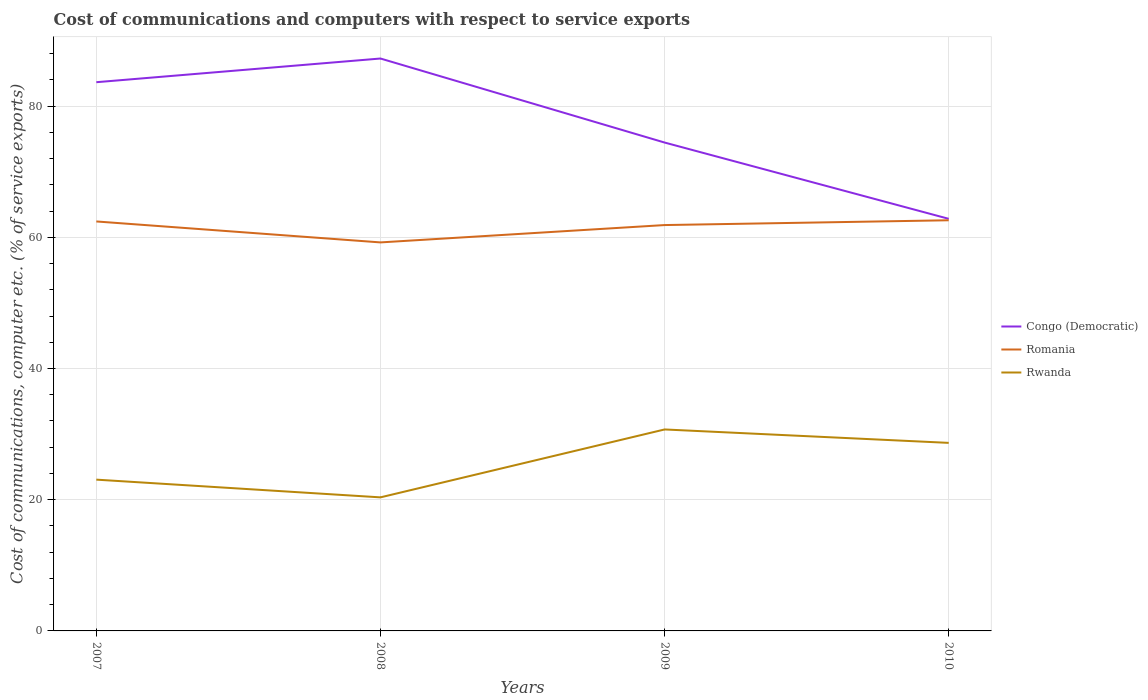Does the line corresponding to Romania intersect with the line corresponding to Congo (Democratic)?
Your answer should be very brief. No. Across all years, what is the maximum cost of communications and computers in Congo (Democratic)?
Ensure brevity in your answer.  62.82. What is the total cost of communications and computers in Congo (Democratic) in the graph?
Your response must be concise. 12.81. What is the difference between the highest and the second highest cost of communications and computers in Congo (Democratic)?
Your answer should be compact. 24.43. What is the difference between two consecutive major ticks on the Y-axis?
Provide a succinct answer. 20. Where does the legend appear in the graph?
Provide a succinct answer. Center right. How are the legend labels stacked?
Make the answer very short. Vertical. What is the title of the graph?
Make the answer very short. Cost of communications and computers with respect to service exports. Does "Morocco" appear as one of the legend labels in the graph?
Offer a very short reply. No. What is the label or title of the Y-axis?
Keep it short and to the point. Cost of communications, computer etc. (% of service exports). What is the Cost of communications, computer etc. (% of service exports) of Congo (Democratic) in 2007?
Provide a succinct answer. 83.64. What is the Cost of communications, computer etc. (% of service exports) of Romania in 2007?
Give a very brief answer. 62.41. What is the Cost of communications, computer etc. (% of service exports) in Rwanda in 2007?
Keep it short and to the point. 23.06. What is the Cost of communications, computer etc. (% of service exports) in Congo (Democratic) in 2008?
Your answer should be compact. 87.25. What is the Cost of communications, computer etc. (% of service exports) in Romania in 2008?
Keep it short and to the point. 59.22. What is the Cost of communications, computer etc. (% of service exports) in Rwanda in 2008?
Make the answer very short. 20.36. What is the Cost of communications, computer etc. (% of service exports) of Congo (Democratic) in 2009?
Your response must be concise. 74.44. What is the Cost of communications, computer etc. (% of service exports) of Romania in 2009?
Your response must be concise. 61.86. What is the Cost of communications, computer etc. (% of service exports) in Rwanda in 2009?
Give a very brief answer. 30.71. What is the Cost of communications, computer etc. (% of service exports) of Congo (Democratic) in 2010?
Keep it short and to the point. 62.82. What is the Cost of communications, computer etc. (% of service exports) in Romania in 2010?
Your answer should be compact. 62.59. What is the Cost of communications, computer etc. (% of service exports) of Rwanda in 2010?
Provide a short and direct response. 28.66. Across all years, what is the maximum Cost of communications, computer etc. (% of service exports) of Congo (Democratic)?
Keep it short and to the point. 87.25. Across all years, what is the maximum Cost of communications, computer etc. (% of service exports) in Romania?
Provide a succinct answer. 62.59. Across all years, what is the maximum Cost of communications, computer etc. (% of service exports) of Rwanda?
Your response must be concise. 30.71. Across all years, what is the minimum Cost of communications, computer etc. (% of service exports) in Congo (Democratic)?
Offer a very short reply. 62.82. Across all years, what is the minimum Cost of communications, computer etc. (% of service exports) in Romania?
Your answer should be very brief. 59.22. Across all years, what is the minimum Cost of communications, computer etc. (% of service exports) of Rwanda?
Ensure brevity in your answer.  20.36. What is the total Cost of communications, computer etc. (% of service exports) of Congo (Democratic) in the graph?
Make the answer very short. 308.15. What is the total Cost of communications, computer etc. (% of service exports) in Romania in the graph?
Give a very brief answer. 246.09. What is the total Cost of communications, computer etc. (% of service exports) in Rwanda in the graph?
Offer a terse response. 102.79. What is the difference between the Cost of communications, computer etc. (% of service exports) in Congo (Democratic) in 2007 and that in 2008?
Keep it short and to the point. -3.61. What is the difference between the Cost of communications, computer etc. (% of service exports) of Romania in 2007 and that in 2008?
Offer a terse response. 3.19. What is the difference between the Cost of communications, computer etc. (% of service exports) in Rwanda in 2007 and that in 2008?
Offer a terse response. 2.7. What is the difference between the Cost of communications, computer etc. (% of service exports) in Congo (Democratic) in 2007 and that in 2009?
Your answer should be compact. 9.2. What is the difference between the Cost of communications, computer etc. (% of service exports) of Romania in 2007 and that in 2009?
Offer a very short reply. 0.55. What is the difference between the Cost of communications, computer etc. (% of service exports) in Rwanda in 2007 and that in 2009?
Offer a very short reply. -7.65. What is the difference between the Cost of communications, computer etc. (% of service exports) in Congo (Democratic) in 2007 and that in 2010?
Provide a succinct answer. 20.82. What is the difference between the Cost of communications, computer etc. (% of service exports) in Romania in 2007 and that in 2010?
Your answer should be compact. -0.18. What is the difference between the Cost of communications, computer etc. (% of service exports) of Rwanda in 2007 and that in 2010?
Provide a short and direct response. -5.61. What is the difference between the Cost of communications, computer etc. (% of service exports) in Congo (Democratic) in 2008 and that in 2009?
Your answer should be compact. 12.81. What is the difference between the Cost of communications, computer etc. (% of service exports) of Romania in 2008 and that in 2009?
Make the answer very short. -2.64. What is the difference between the Cost of communications, computer etc. (% of service exports) in Rwanda in 2008 and that in 2009?
Your answer should be very brief. -10.35. What is the difference between the Cost of communications, computer etc. (% of service exports) of Congo (Democratic) in 2008 and that in 2010?
Keep it short and to the point. 24.43. What is the difference between the Cost of communications, computer etc. (% of service exports) of Romania in 2008 and that in 2010?
Provide a succinct answer. -3.37. What is the difference between the Cost of communications, computer etc. (% of service exports) in Rwanda in 2008 and that in 2010?
Provide a succinct answer. -8.3. What is the difference between the Cost of communications, computer etc. (% of service exports) of Congo (Democratic) in 2009 and that in 2010?
Provide a short and direct response. 11.63. What is the difference between the Cost of communications, computer etc. (% of service exports) in Romania in 2009 and that in 2010?
Ensure brevity in your answer.  -0.73. What is the difference between the Cost of communications, computer etc. (% of service exports) of Rwanda in 2009 and that in 2010?
Provide a short and direct response. 2.04. What is the difference between the Cost of communications, computer etc. (% of service exports) in Congo (Democratic) in 2007 and the Cost of communications, computer etc. (% of service exports) in Romania in 2008?
Your answer should be very brief. 24.42. What is the difference between the Cost of communications, computer etc. (% of service exports) in Congo (Democratic) in 2007 and the Cost of communications, computer etc. (% of service exports) in Rwanda in 2008?
Give a very brief answer. 63.28. What is the difference between the Cost of communications, computer etc. (% of service exports) of Romania in 2007 and the Cost of communications, computer etc. (% of service exports) of Rwanda in 2008?
Your response must be concise. 42.05. What is the difference between the Cost of communications, computer etc. (% of service exports) of Congo (Democratic) in 2007 and the Cost of communications, computer etc. (% of service exports) of Romania in 2009?
Provide a short and direct response. 21.78. What is the difference between the Cost of communications, computer etc. (% of service exports) in Congo (Democratic) in 2007 and the Cost of communications, computer etc. (% of service exports) in Rwanda in 2009?
Your response must be concise. 52.93. What is the difference between the Cost of communications, computer etc. (% of service exports) of Romania in 2007 and the Cost of communications, computer etc. (% of service exports) of Rwanda in 2009?
Provide a short and direct response. 31.71. What is the difference between the Cost of communications, computer etc. (% of service exports) in Congo (Democratic) in 2007 and the Cost of communications, computer etc. (% of service exports) in Romania in 2010?
Your answer should be compact. 21.05. What is the difference between the Cost of communications, computer etc. (% of service exports) of Congo (Democratic) in 2007 and the Cost of communications, computer etc. (% of service exports) of Rwanda in 2010?
Give a very brief answer. 54.98. What is the difference between the Cost of communications, computer etc. (% of service exports) in Romania in 2007 and the Cost of communications, computer etc. (% of service exports) in Rwanda in 2010?
Your answer should be very brief. 33.75. What is the difference between the Cost of communications, computer etc. (% of service exports) in Congo (Democratic) in 2008 and the Cost of communications, computer etc. (% of service exports) in Romania in 2009?
Ensure brevity in your answer.  25.39. What is the difference between the Cost of communications, computer etc. (% of service exports) in Congo (Democratic) in 2008 and the Cost of communications, computer etc. (% of service exports) in Rwanda in 2009?
Offer a very short reply. 56.54. What is the difference between the Cost of communications, computer etc. (% of service exports) of Romania in 2008 and the Cost of communications, computer etc. (% of service exports) of Rwanda in 2009?
Your answer should be compact. 28.51. What is the difference between the Cost of communications, computer etc. (% of service exports) in Congo (Democratic) in 2008 and the Cost of communications, computer etc. (% of service exports) in Romania in 2010?
Give a very brief answer. 24.66. What is the difference between the Cost of communications, computer etc. (% of service exports) of Congo (Democratic) in 2008 and the Cost of communications, computer etc. (% of service exports) of Rwanda in 2010?
Offer a terse response. 58.59. What is the difference between the Cost of communications, computer etc. (% of service exports) in Romania in 2008 and the Cost of communications, computer etc. (% of service exports) in Rwanda in 2010?
Your response must be concise. 30.56. What is the difference between the Cost of communications, computer etc. (% of service exports) of Congo (Democratic) in 2009 and the Cost of communications, computer etc. (% of service exports) of Romania in 2010?
Make the answer very short. 11.85. What is the difference between the Cost of communications, computer etc. (% of service exports) of Congo (Democratic) in 2009 and the Cost of communications, computer etc. (% of service exports) of Rwanda in 2010?
Your response must be concise. 45.78. What is the difference between the Cost of communications, computer etc. (% of service exports) of Romania in 2009 and the Cost of communications, computer etc. (% of service exports) of Rwanda in 2010?
Offer a terse response. 33.2. What is the average Cost of communications, computer etc. (% of service exports) in Congo (Democratic) per year?
Your answer should be very brief. 77.04. What is the average Cost of communications, computer etc. (% of service exports) of Romania per year?
Give a very brief answer. 61.52. What is the average Cost of communications, computer etc. (% of service exports) in Rwanda per year?
Offer a very short reply. 25.7. In the year 2007, what is the difference between the Cost of communications, computer etc. (% of service exports) of Congo (Democratic) and Cost of communications, computer etc. (% of service exports) of Romania?
Your answer should be very brief. 21.23. In the year 2007, what is the difference between the Cost of communications, computer etc. (% of service exports) of Congo (Democratic) and Cost of communications, computer etc. (% of service exports) of Rwanda?
Make the answer very short. 60.58. In the year 2007, what is the difference between the Cost of communications, computer etc. (% of service exports) in Romania and Cost of communications, computer etc. (% of service exports) in Rwanda?
Ensure brevity in your answer.  39.36. In the year 2008, what is the difference between the Cost of communications, computer etc. (% of service exports) in Congo (Democratic) and Cost of communications, computer etc. (% of service exports) in Romania?
Keep it short and to the point. 28.03. In the year 2008, what is the difference between the Cost of communications, computer etc. (% of service exports) in Congo (Democratic) and Cost of communications, computer etc. (% of service exports) in Rwanda?
Offer a very short reply. 66.89. In the year 2008, what is the difference between the Cost of communications, computer etc. (% of service exports) of Romania and Cost of communications, computer etc. (% of service exports) of Rwanda?
Provide a short and direct response. 38.86. In the year 2009, what is the difference between the Cost of communications, computer etc. (% of service exports) in Congo (Democratic) and Cost of communications, computer etc. (% of service exports) in Romania?
Give a very brief answer. 12.58. In the year 2009, what is the difference between the Cost of communications, computer etc. (% of service exports) in Congo (Democratic) and Cost of communications, computer etc. (% of service exports) in Rwanda?
Provide a succinct answer. 43.73. In the year 2009, what is the difference between the Cost of communications, computer etc. (% of service exports) in Romania and Cost of communications, computer etc. (% of service exports) in Rwanda?
Provide a succinct answer. 31.15. In the year 2010, what is the difference between the Cost of communications, computer etc. (% of service exports) in Congo (Democratic) and Cost of communications, computer etc. (% of service exports) in Romania?
Your response must be concise. 0.22. In the year 2010, what is the difference between the Cost of communications, computer etc. (% of service exports) of Congo (Democratic) and Cost of communications, computer etc. (% of service exports) of Rwanda?
Provide a short and direct response. 34.15. In the year 2010, what is the difference between the Cost of communications, computer etc. (% of service exports) in Romania and Cost of communications, computer etc. (% of service exports) in Rwanda?
Offer a terse response. 33.93. What is the ratio of the Cost of communications, computer etc. (% of service exports) in Congo (Democratic) in 2007 to that in 2008?
Give a very brief answer. 0.96. What is the ratio of the Cost of communications, computer etc. (% of service exports) of Romania in 2007 to that in 2008?
Your answer should be very brief. 1.05. What is the ratio of the Cost of communications, computer etc. (% of service exports) in Rwanda in 2007 to that in 2008?
Provide a short and direct response. 1.13. What is the ratio of the Cost of communications, computer etc. (% of service exports) of Congo (Democratic) in 2007 to that in 2009?
Offer a very short reply. 1.12. What is the ratio of the Cost of communications, computer etc. (% of service exports) of Romania in 2007 to that in 2009?
Give a very brief answer. 1.01. What is the ratio of the Cost of communications, computer etc. (% of service exports) in Rwanda in 2007 to that in 2009?
Offer a very short reply. 0.75. What is the ratio of the Cost of communications, computer etc. (% of service exports) of Congo (Democratic) in 2007 to that in 2010?
Keep it short and to the point. 1.33. What is the ratio of the Cost of communications, computer etc. (% of service exports) in Romania in 2007 to that in 2010?
Provide a short and direct response. 1. What is the ratio of the Cost of communications, computer etc. (% of service exports) of Rwanda in 2007 to that in 2010?
Your response must be concise. 0.8. What is the ratio of the Cost of communications, computer etc. (% of service exports) in Congo (Democratic) in 2008 to that in 2009?
Your response must be concise. 1.17. What is the ratio of the Cost of communications, computer etc. (% of service exports) of Romania in 2008 to that in 2009?
Your answer should be compact. 0.96. What is the ratio of the Cost of communications, computer etc. (% of service exports) of Rwanda in 2008 to that in 2009?
Make the answer very short. 0.66. What is the ratio of the Cost of communications, computer etc. (% of service exports) of Congo (Democratic) in 2008 to that in 2010?
Provide a short and direct response. 1.39. What is the ratio of the Cost of communications, computer etc. (% of service exports) in Romania in 2008 to that in 2010?
Your answer should be very brief. 0.95. What is the ratio of the Cost of communications, computer etc. (% of service exports) of Rwanda in 2008 to that in 2010?
Keep it short and to the point. 0.71. What is the ratio of the Cost of communications, computer etc. (% of service exports) in Congo (Democratic) in 2009 to that in 2010?
Keep it short and to the point. 1.19. What is the ratio of the Cost of communications, computer etc. (% of service exports) of Romania in 2009 to that in 2010?
Give a very brief answer. 0.99. What is the ratio of the Cost of communications, computer etc. (% of service exports) of Rwanda in 2009 to that in 2010?
Offer a very short reply. 1.07. What is the difference between the highest and the second highest Cost of communications, computer etc. (% of service exports) of Congo (Democratic)?
Provide a short and direct response. 3.61. What is the difference between the highest and the second highest Cost of communications, computer etc. (% of service exports) in Romania?
Keep it short and to the point. 0.18. What is the difference between the highest and the second highest Cost of communications, computer etc. (% of service exports) of Rwanda?
Offer a very short reply. 2.04. What is the difference between the highest and the lowest Cost of communications, computer etc. (% of service exports) of Congo (Democratic)?
Ensure brevity in your answer.  24.43. What is the difference between the highest and the lowest Cost of communications, computer etc. (% of service exports) in Romania?
Make the answer very short. 3.37. What is the difference between the highest and the lowest Cost of communications, computer etc. (% of service exports) of Rwanda?
Give a very brief answer. 10.35. 